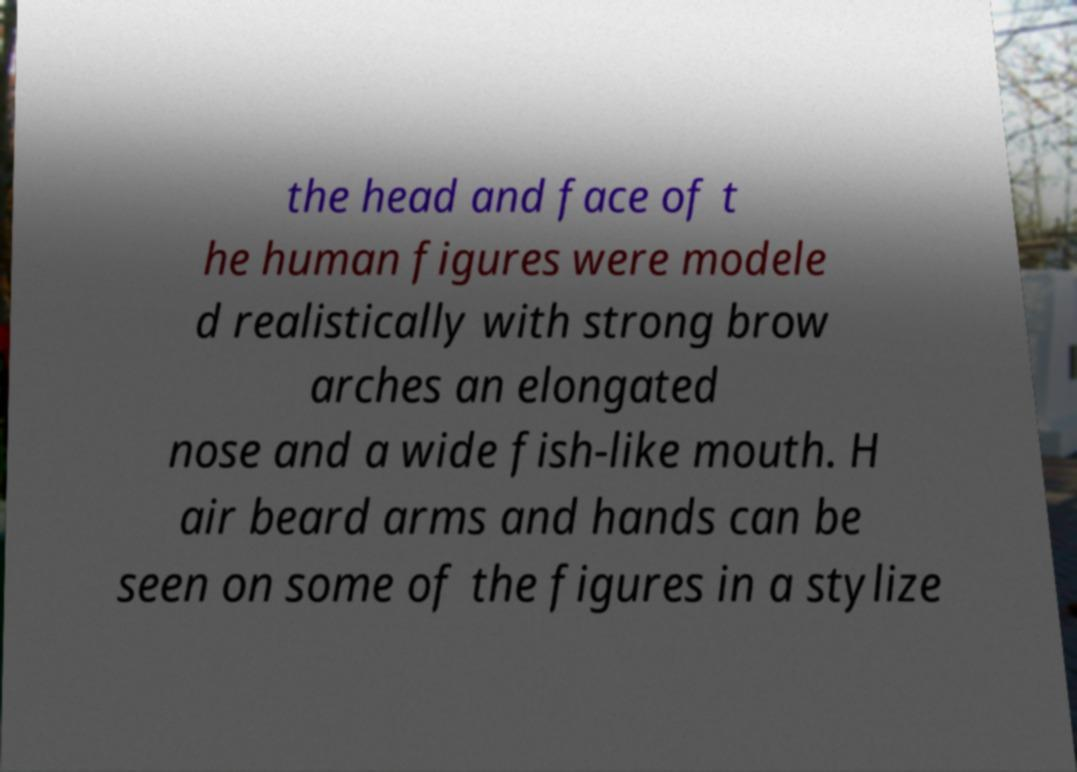Can you read and provide the text displayed in the image?This photo seems to have some interesting text. Can you extract and type it out for me? the head and face of t he human figures were modele d realistically with strong brow arches an elongated nose and a wide fish-like mouth. H air beard arms and hands can be seen on some of the figures in a stylize 